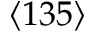<formula> <loc_0><loc_0><loc_500><loc_500>\langle 1 3 5 \rangle</formula> 